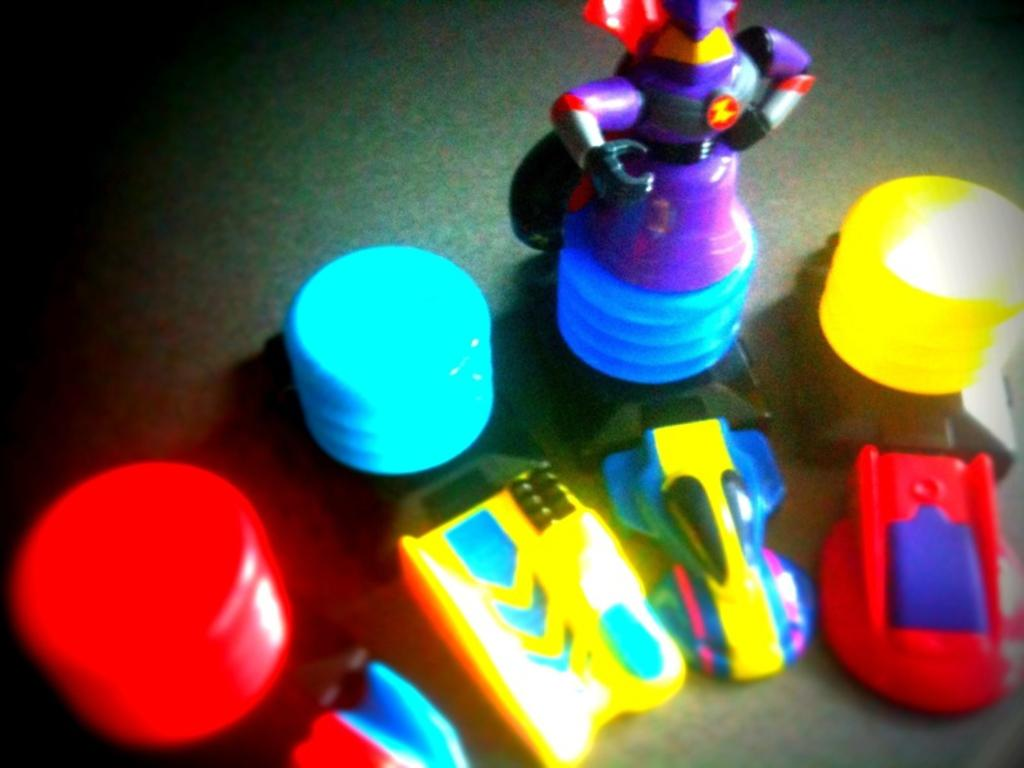What type of toys can be seen in the image? There are toy cars in the image. Are there any other types of toys besides the toy cars? Yes, there are other toys in the image. What color is the soap in the image? There is no soap present in the image. How many volleyballs can be seen in the image? There are no volleyballs present in the image. 